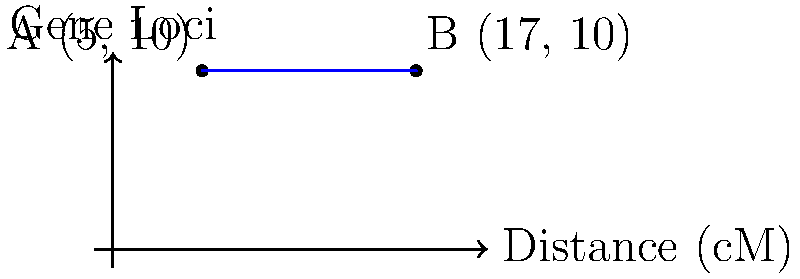On a linear chromosome map, two gene loci A and B are represented by points (5, 10) and (17, 10) respectively, where the x-axis represents genetic distance in centimorgans (cM). Calculate the genetic distance between these two loci. To calculate the genetic distance between two gene loci on a linear chromosome map, we need to find the distance between their x-coordinates, as the y-coordinate (10) is the same for both points.

Step 1: Identify the x-coordinates of the two points:
Point A: $(x_1, y_1) = (5, 10)$
Point B: $(x_2, y_2) = (17, 10)$

Step 2: Calculate the difference between the x-coordinates:
Distance = $|x_2 - x_1|$
Distance = $|17 - 5|$
Distance = $12$

Since the x-axis represents genetic distance in centimorgans (cM), the genetic distance between the two loci is 12 cM.
Answer: 12 cM 